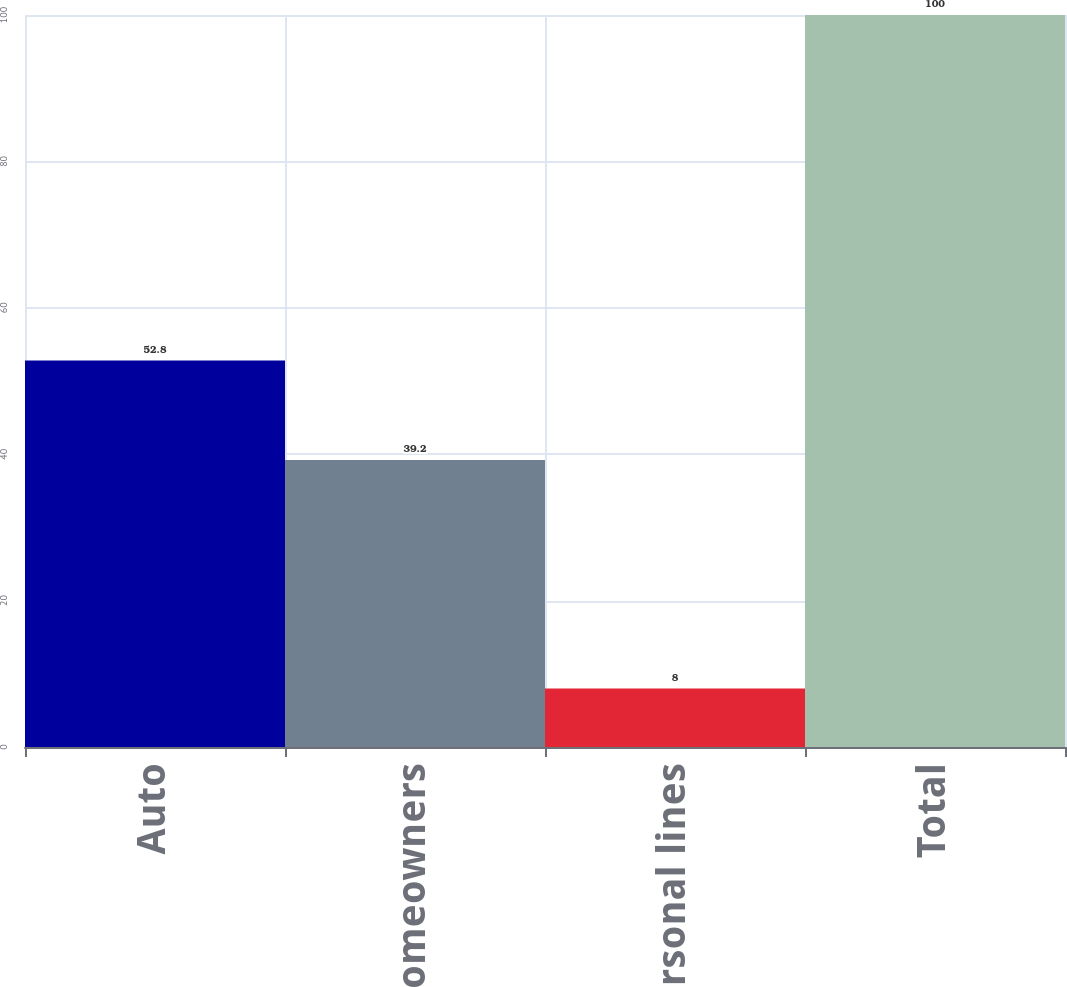Convert chart. <chart><loc_0><loc_0><loc_500><loc_500><bar_chart><fcel>Auto<fcel>Homeowners<fcel>Other personal lines<fcel>Total<nl><fcel>52.8<fcel>39.2<fcel>8<fcel>100<nl></chart> 